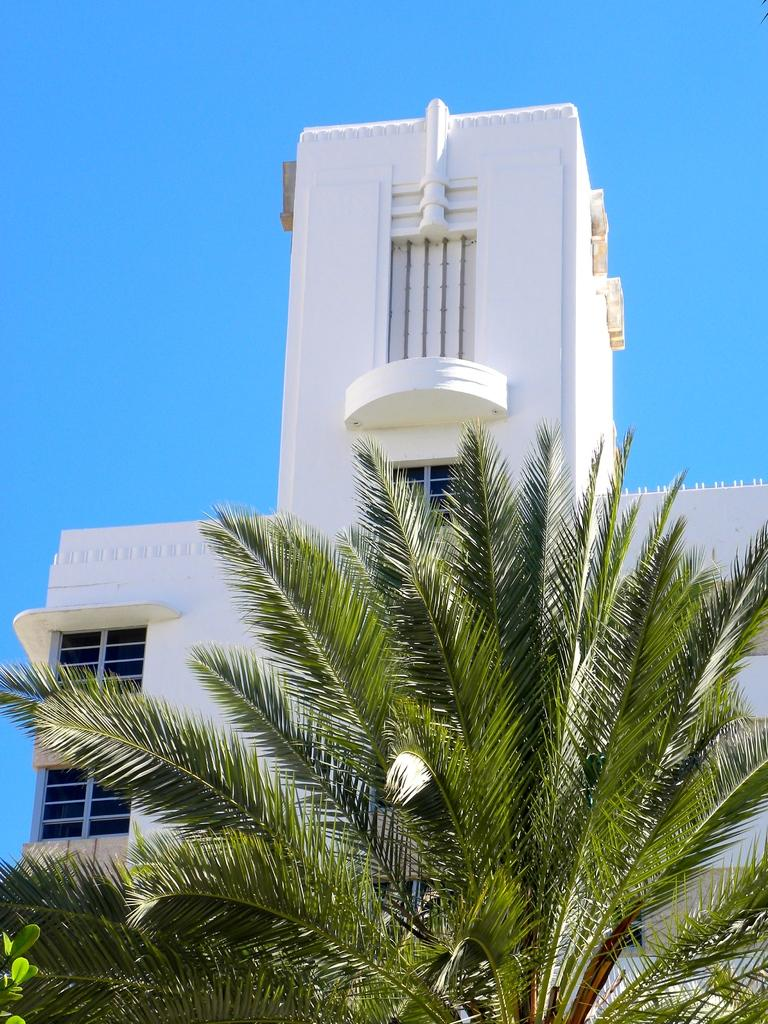What is the main subject in the center of the image? There is a building in the center of the image. What can be seen at the bottom of the image? There is a tree at the bottom of the image. What is visible in the background of the image? The sky is visible in the background of the image. Where is the hydrant located in the image? There is no hydrant present in the image. Can you describe the movement of the swing in the image? There is no swing present in the image. 